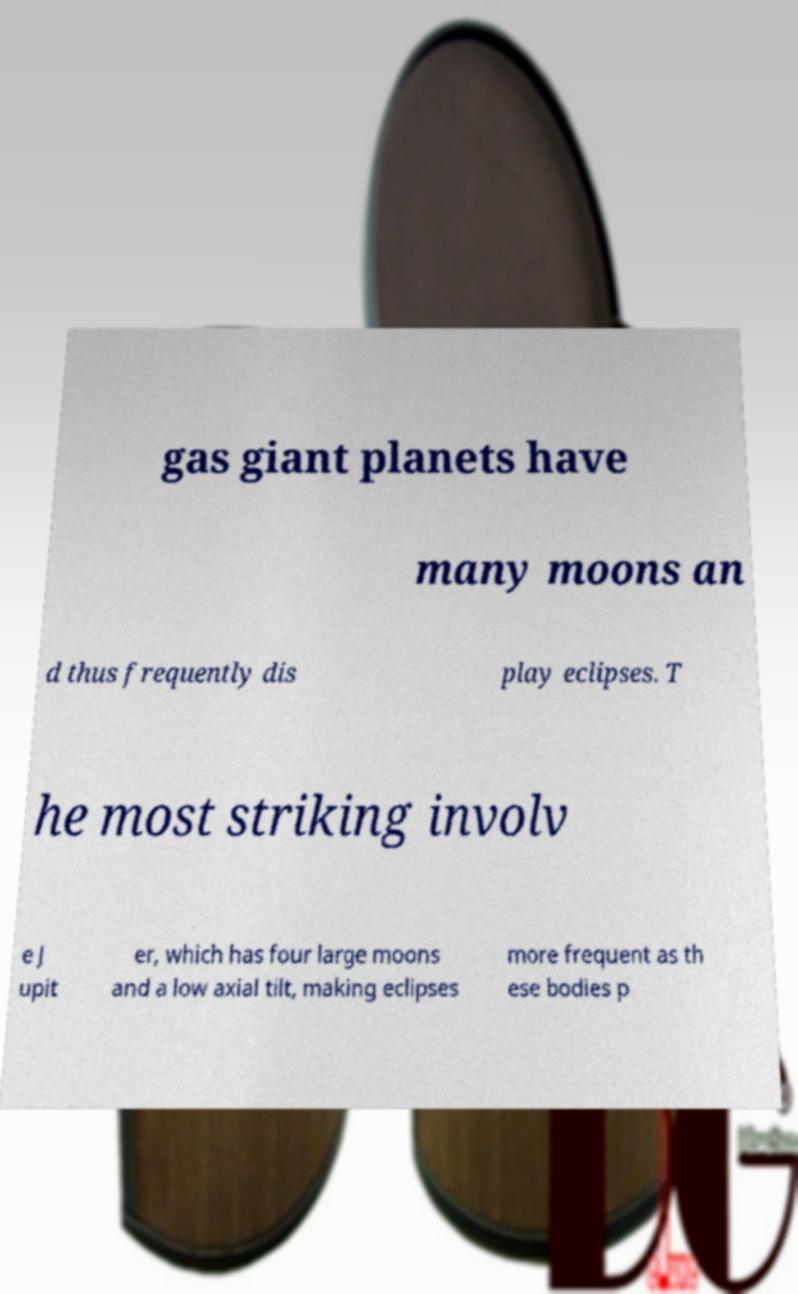Could you assist in decoding the text presented in this image and type it out clearly? gas giant planets have many moons an d thus frequently dis play eclipses. T he most striking involv e J upit er, which has four large moons and a low axial tilt, making eclipses more frequent as th ese bodies p 